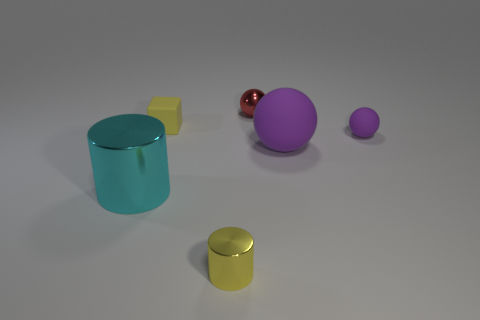Is there any other thing that is the same shape as the yellow matte thing?
Offer a terse response. No. There is a small metallic object behind the small metal cylinder; does it have the same color as the large metal object?
Your answer should be very brief. No. What is the size of the other rubber object that is the same shape as the large purple matte thing?
Provide a short and direct response. Small. How many other purple spheres are the same material as the big purple sphere?
Your answer should be very brief. 1. Are there any small yellow cubes that are in front of the yellow object on the left side of the tiny shiny thing in front of the red ball?
Keep it short and to the point. No. What is the shape of the small purple matte object?
Your response must be concise. Sphere. Do the small purple sphere behind the cyan object and the small yellow thing that is behind the big metal object have the same material?
Keep it short and to the point. Yes. How many metal things have the same color as the metallic sphere?
Make the answer very short. 0. There is a thing that is both right of the small metal ball and left of the tiny purple object; what shape is it?
Provide a short and direct response. Sphere. What is the color of the small object that is both left of the tiny purple rubber ball and in front of the matte block?
Provide a short and direct response. Yellow. 